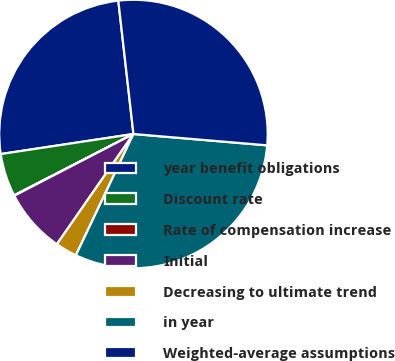<chart> <loc_0><loc_0><loc_500><loc_500><pie_chart><fcel>year benefit obligations<fcel>Discount rate<fcel>Rate of compensation increase<fcel>Initial<fcel>Decreasing to ultimate trend<fcel>in year<fcel>Weighted-average assumptions<nl><fcel>25.59%<fcel>5.17%<fcel>0.05%<fcel>7.73%<fcel>2.61%<fcel>30.71%<fcel>28.15%<nl></chart> 